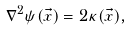Convert formula to latex. <formula><loc_0><loc_0><loc_500><loc_500>\nabla ^ { 2 } \psi ( \vec { x } ) = 2 \kappa ( \vec { x } ) ,</formula> 